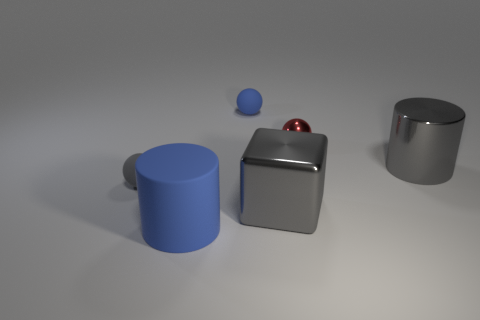Subtract all metal balls. How many balls are left? 2 Add 2 small gray balls. How many objects exist? 8 Subtract all blue balls. How many balls are left? 2 Subtract 2 balls. How many balls are left? 1 Add 1 shiny cylinders. How many shiny cylinders are left? 2 Add 3 big cyan shiny spheres. How many big cyan shiny spheres exist? 3 Subtract 0 green spheres. How many objects are left? 6 Subtract all cubes. How many objects are left? 5 Subtract all yellow cylinders. Subtract all purple cubes. How many cylinders are left? 2 Subtract all gray cubes. Subtract all blue matte things. How many objects are left? 3 